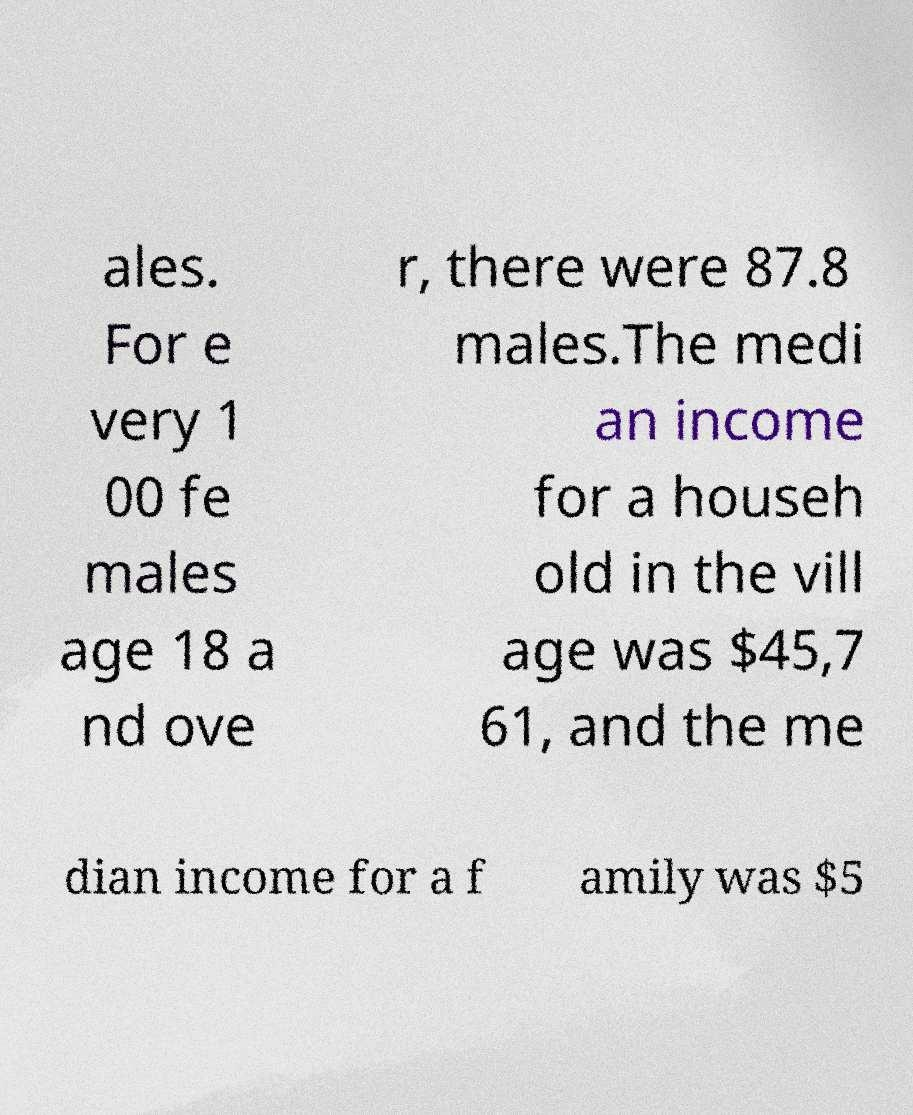Please identify and transcribe the text found in this image. ales. For e very 1 00 fe males age 18 a nd ove r, there were 87.8 males.The medi an income for a househ old in the vill age was $45,7 61, and the me dian income for a f amily was $5 